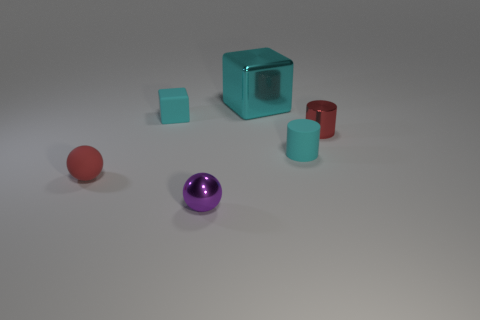There is a rubber cube that is the same color as the matte cylinder; what is its size?
Offer a terse response. Small. There is a block that is behind the cyan matte block; what color is it?
Your response must be concise. Cyan. There is a tiny red thing that is made of the same material as the big cyan thing; what shape is it?
Keep it short and to the point. Cylinder. Are there any other things that have the same color as the big object?
Provide a succinct answer. Yes. Is the number of cyan metallic objects in front of the tiny red cylinder greater than the number of tiny cyan things that are on the left side of the small block?
Offer a terse response. No. What number of matte cubes are the same size as the purple ball?
Provide a succinct answer. 1. Is the number of tiny purple objects behind the cyan metallic block less than the number of cyan matte things that are behind the red shiny cylinder?
Ensure brevity in your answer.  Yes. Are there any big yellow objects that have the same shape as the small red metal object?
Offer a terse response. No. Does the large object have the same shape as the tiny red rubber thing?
Keep it short and to the point. No. What number of tiny things are either cyan metallic cylinders or purple spheres?
Your answer should be compact. 1. 